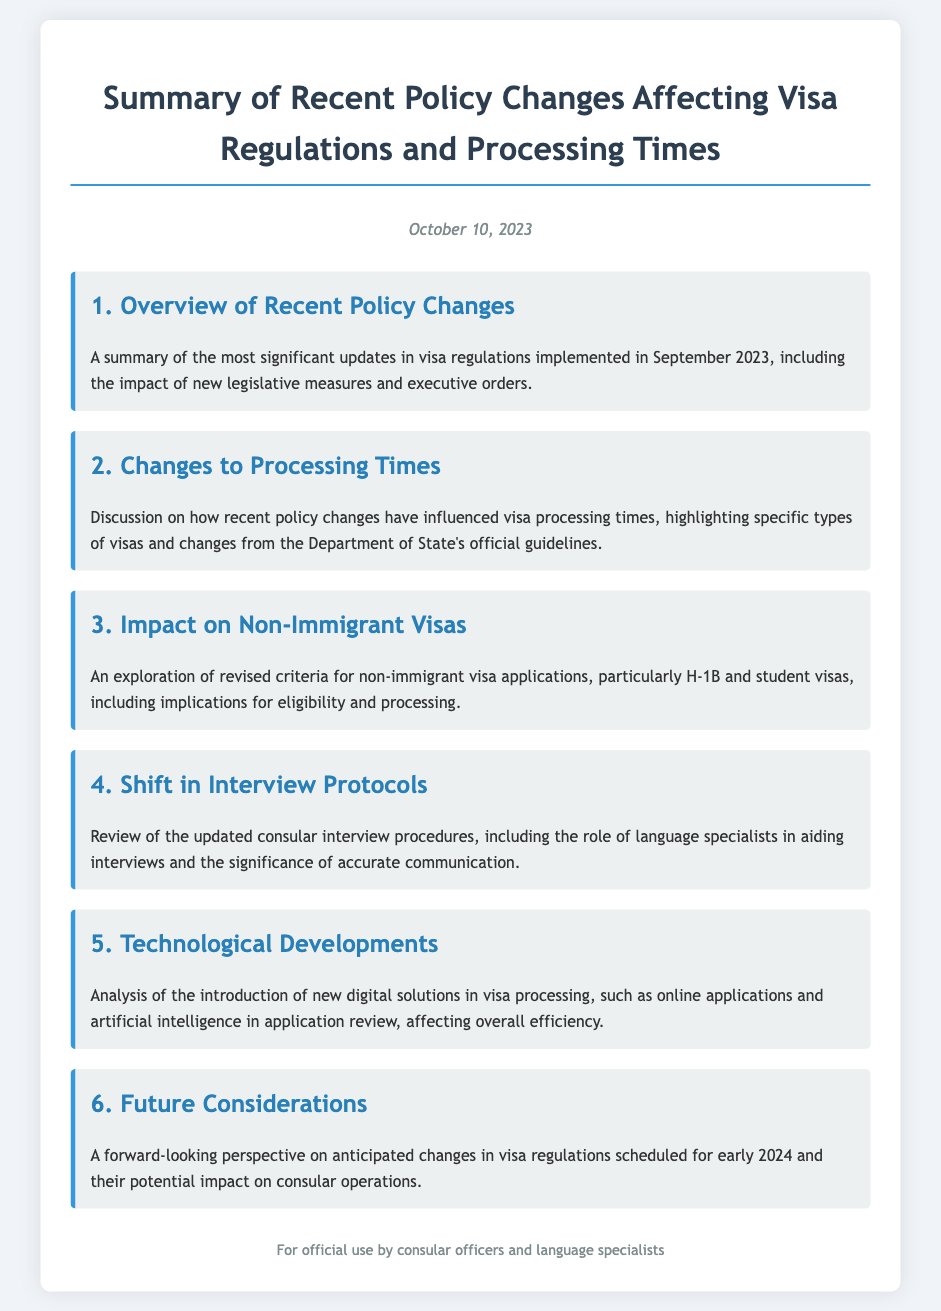What is the date of the document? The document is dated October 10, 2023, as stated at the top.
Answer: October 10, 2023 How many main topics are covered in the document? The document includes six main topics, as outlined in the list.
Answer: 6 What topic addresses non-immigrant visas? The topic discussing non-immigrant visas is specifically titled "Impact on Non-Immigrant Visas."
Answer: Impact on Non-Immigrant Visas What has influenced visa processing times? The document highlights changes due to recent policy changes affecting visa processing times.
Answer: Recent policy changes What is a key focus of the “Shift in Interview Protocols” section? This section reviews updated consular interview procedures and the use of language specialists.
Answer: Updated consular interview procedures What is anticipated for early 2024? The document mentions anticipated changes in visa regulations scheduled for early 2024.
Answer: Changes in visa regulations 